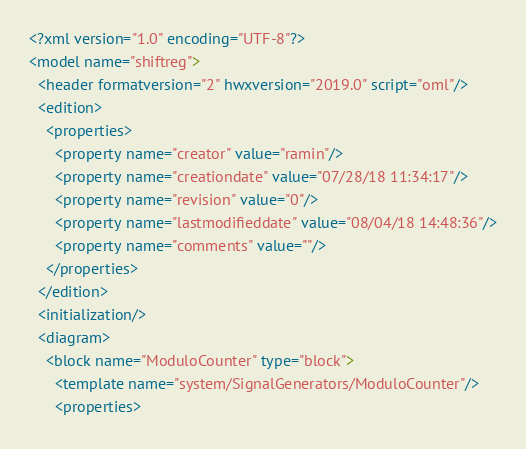Convert code to text. <code><loc_0><loc_0><loc_500><loc_500><_Scheme_><?xml version="1.0" encoding="UTF-8"?>
<model name="shiftreg">
  <header formatversion="2" hwxversion="2019.0" script="oml"/>
  <edition>
    <properties>
      <property name="creator" value="ramin"/>
      <property name="creationdate" value="07/28/18 11:34:17"/>
      <property name="revision" value="0"/>
      <property name="lastmodifieddate" value="08/04/18 14:48:36"/>
      <property name="comments" value=""/>
    </properties>
  </edition>
  <initialization/>
  <diagram>
    <block name="ModuloCounter" type="block">
      <template name="system/SignalGenerators/ModuloCounter"/>
      <properties></code> 